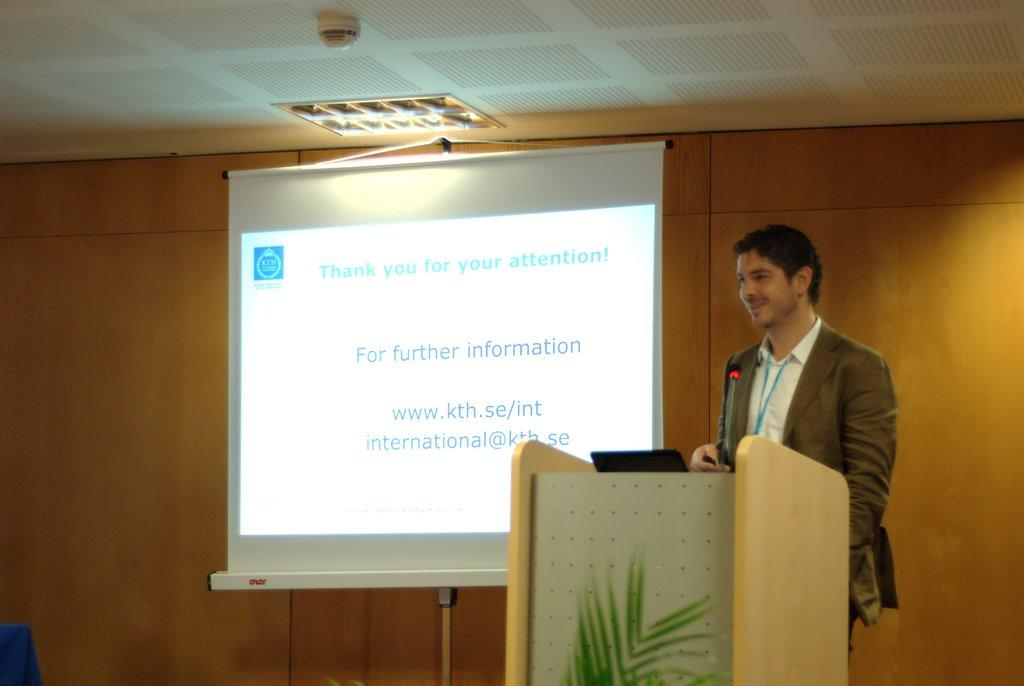<image>
Relay a brief, clear account of the picture shown. a man standing in front of a projection screen that says 'thank you for your attentiont!' on it 